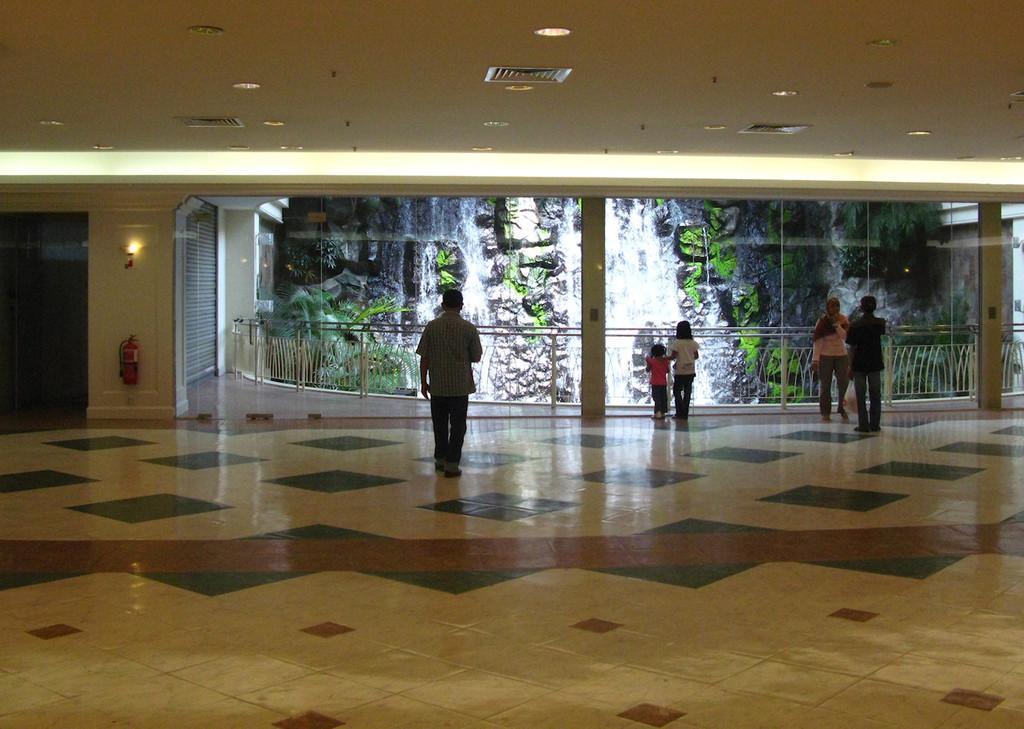Could you give a brief overview of what you see in this image? In this image we can see three men and two girl are standing on the floor. We can see railing, pillars, fire extinguisher, light, wall, shutter and water fall in the middle of the image. There is a roof at the top of the image. 